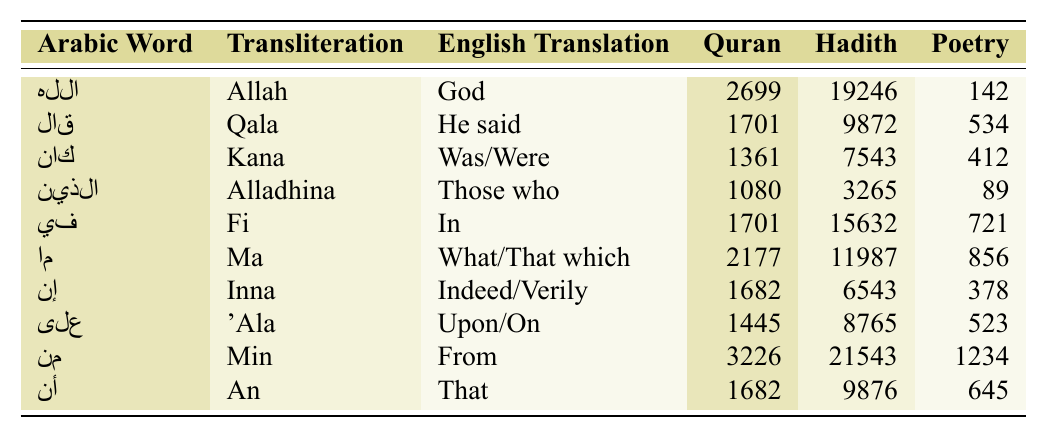What is the Arabic word that means "God"? The table shows the word "الله" which is transliterated as "Allah" and translated as "God."
Answer: الله Which word occurs most frequently in Hadith Collections? By inspecting the occurrences in Hadith Collections, "الله" appears 19246 times, which is more than any other word listed.
Answer: الله What is the total number of occurrences of the word "ما" across all texts? The occurrences of "ما" are 2177 in the Quran, 11987 in Hadith Collections, and 856 in Pre-Islamic Poetry. Adding these gives 2177 + 11987 + 856 = 14920.
Answer: 14920 True or False: The word "كان" occurs more frequently in Pre-Islamic Poetry than in the Quran. "كان" has 412 occurrences in Pre-Islamic Poetry and 1361 in the Quran. Since 412 < 1361, the statement is false.
Answer: False What is the difference in occurrences of the word "من" between the Hadith Collections and Pre-Islamic Poetry? The occurrences of "من" are 21543 in Hadith Collections and 1234 in Pre-Islamic Poetry. The difference is 21543 - 1234 = 20309.
Answer: 20309 Calculate the average occurrences of the word "إن" across the three text categories. For "إن," the occurrences are 1682 in the Quran, 6543 in Hadith Collections, and 378 in Pre-Islamic Poetry. The total is 1682 + 6543 + 378 = 8603, and there are 3 categories, so the average is 8603 / 3 = 2867.67.
Answer: 2867.67 Which word has the fewest occurrences in Pre-Islamic Poetry? By observing the Pre-Islamic Poetry column, "الذين" has the least with only 89 occurrences compared to others.
Answer: الذين Does the word "قال" occur more frequently in the Quran than the word "كان"? "قال" occurs 1701 times in the Quran while "كان" occurs 1361 times. Since 1701 > 1361, the answer is yes.
Answer: Yes What is the total number of occurrences of the word "على" in the Quran and Hadith Collections combined? The occurrences of "على" in the Quran is 1445 and in Hadith Collections is 8765. The total is 1445 + 8765 = 10210.
Answer: 10210 Identify the word with the smallest occurrence in Quran. The word "الذين" has only 1080 occurrences in the Quran, which is less than any other word in that category.
Answer: الذين 